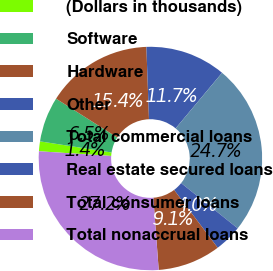<chart> <loc_0><loc_0><loc_500><loc_500><pie_chart><fcel>(Dollars in thousands)<fcel>Software<fcel>Hardware<fcel>Other<fcel>Total commercial loans<fcel>Real estate secured loans<fcel>Total consumer loans<fcel>Total nonaccrual loans<nl><fcel>1.42%<fcel>6.54%<fcel>15.43%<fcel>11.66%<fcel>24.66%<fcel>3.98%<fcel>9.1%<fcel>27.22%<nl></chart> 